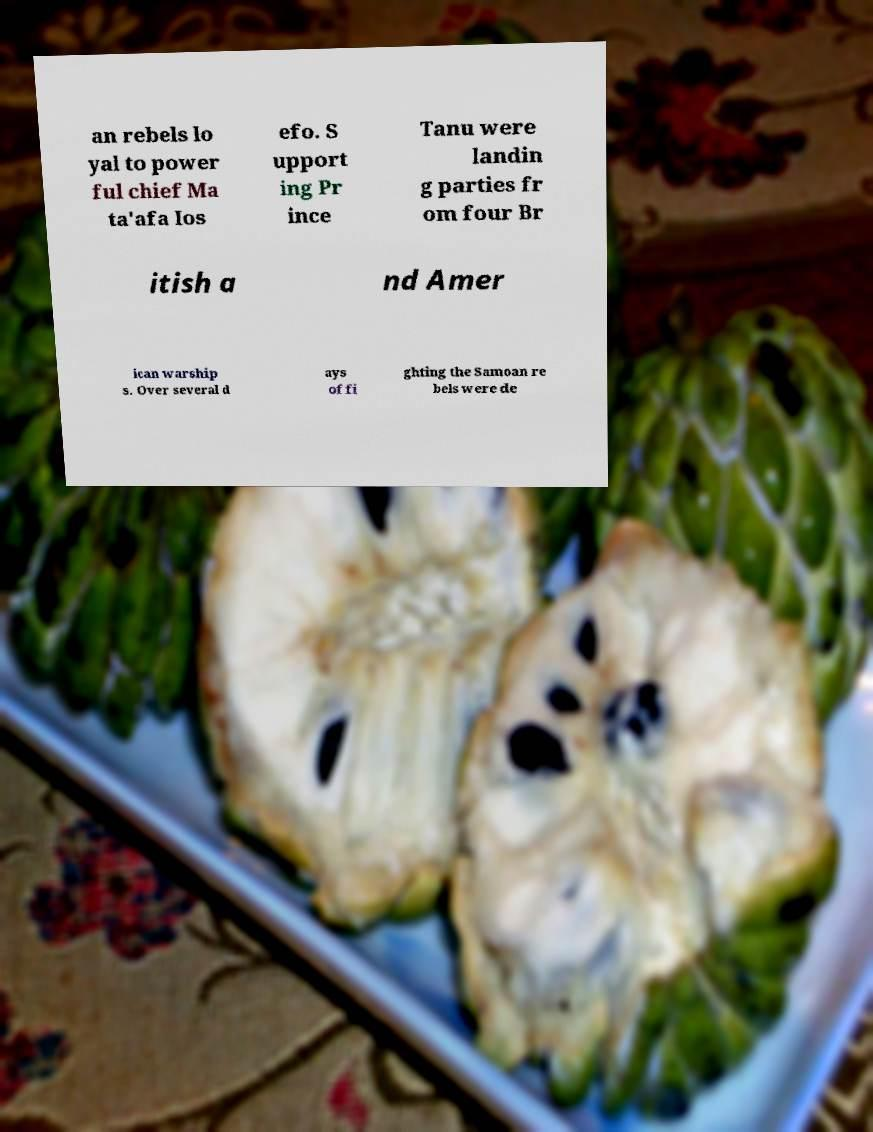Please identify and transcribe the text found in this image. an rebels lo yal to power ful chief Ma ta'afa Ios efo. S upport ing Pr ince Tanu were landin g parties fr om four Br itish a nd Amer ican warship s. Over several d ays of fi ghting the Samoan re bels were de 